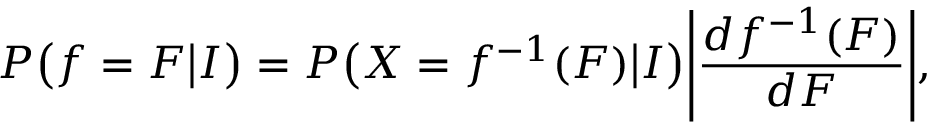<formula> <loc_0><loc_0><loc_500><loc_500>P \left ( f = F \left | I \right ) = P \left ( X = f ^ { - 1 } ( F ) \right | I \right ) \left | \frac { d f ^ { - 1 } ( F ) } { d F } \right | ,</formula> 